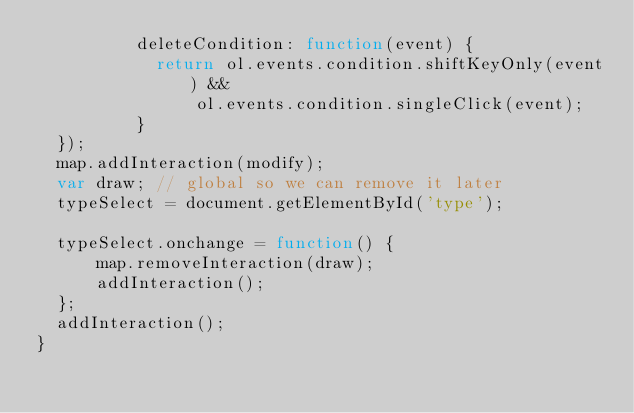Convert code to text. <code><loc_0><loc_0><loc_500><loc_500><_JavaScript_>	        deleteCondition: function(event) {
	          return ol.events.condition.shiftKeyOnly(event) &&
	              ol.events.condition.singleClick(event);
	        }
	});
	map.addInteraction(modify);
	var draw; // global so we can remove it later
	typeSelect = document.getElementById('type');

	typeSelect.onchange = function() {
	    map.removeInteraction(draw);
	    addInteraction();
	};
	addInteraction();
}
</code> 